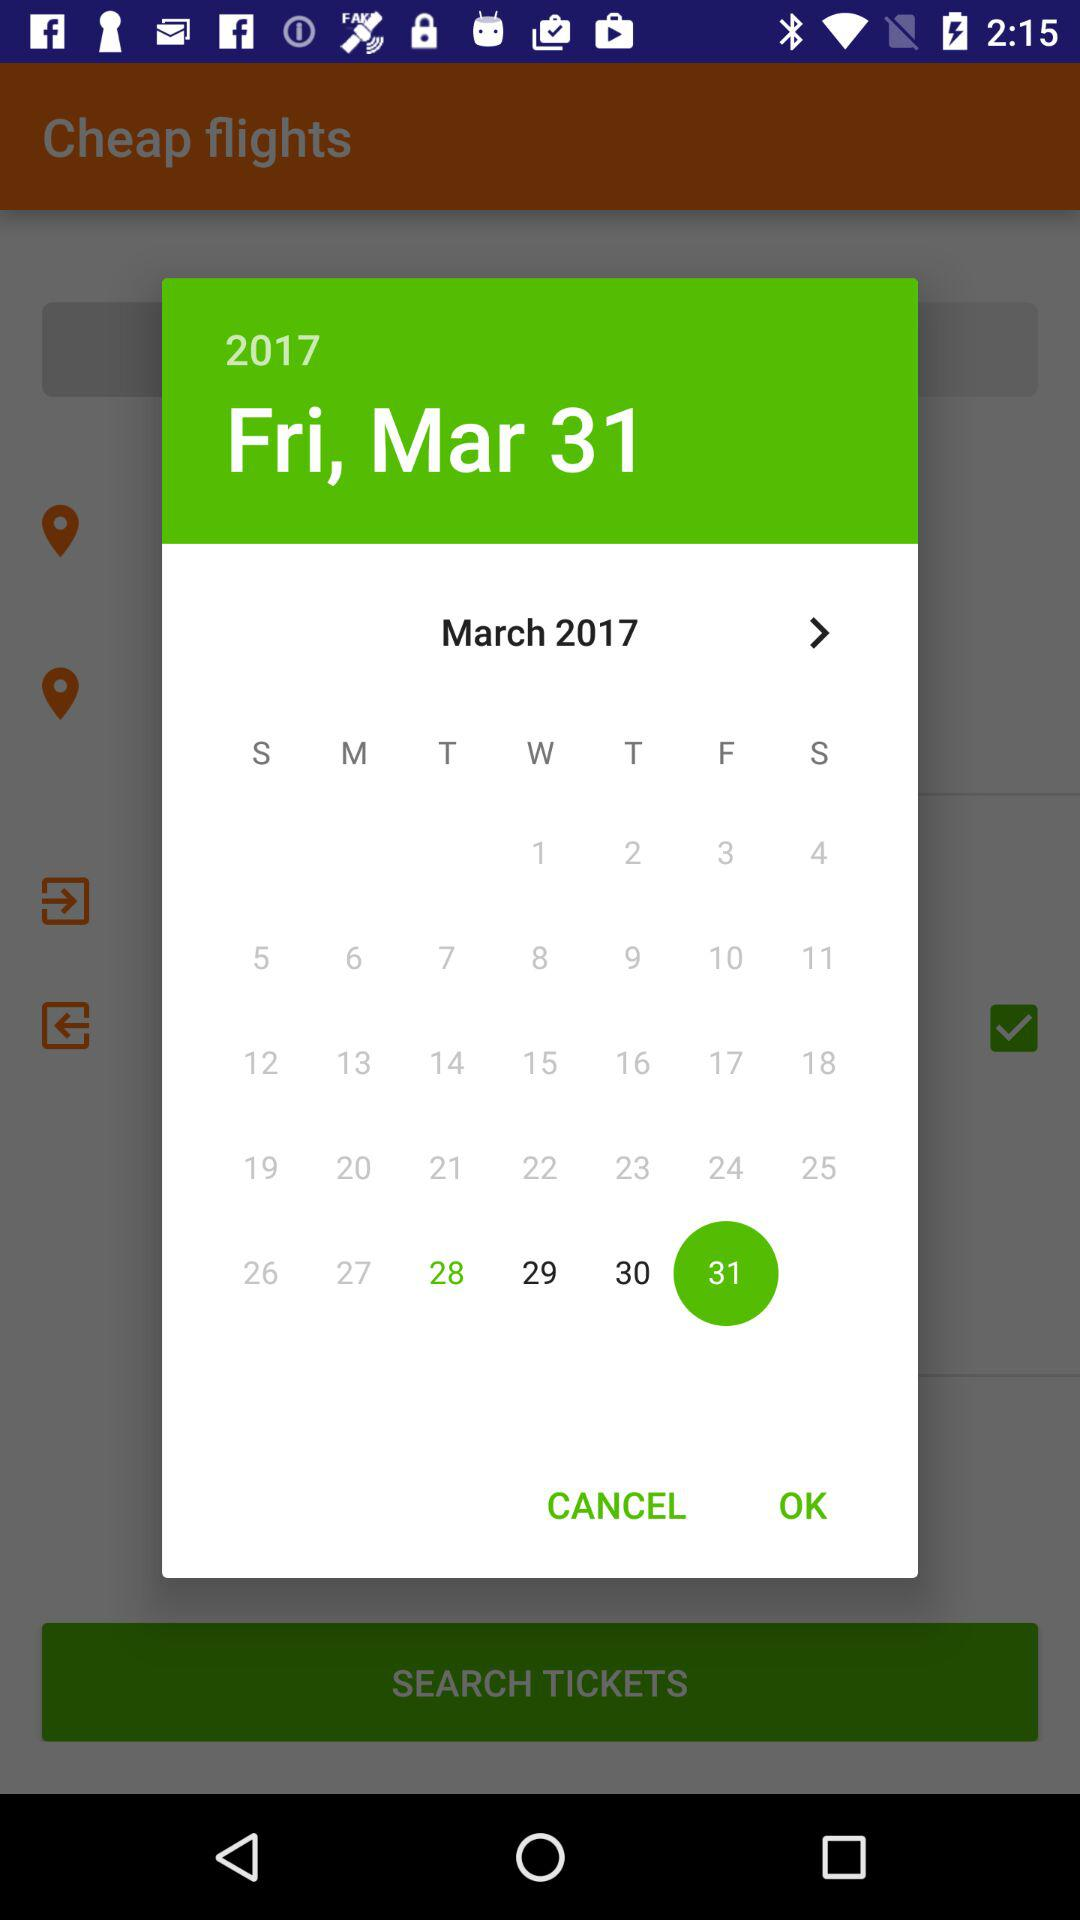What is the selected date? The selected date is Friday, March 31, 2017. 